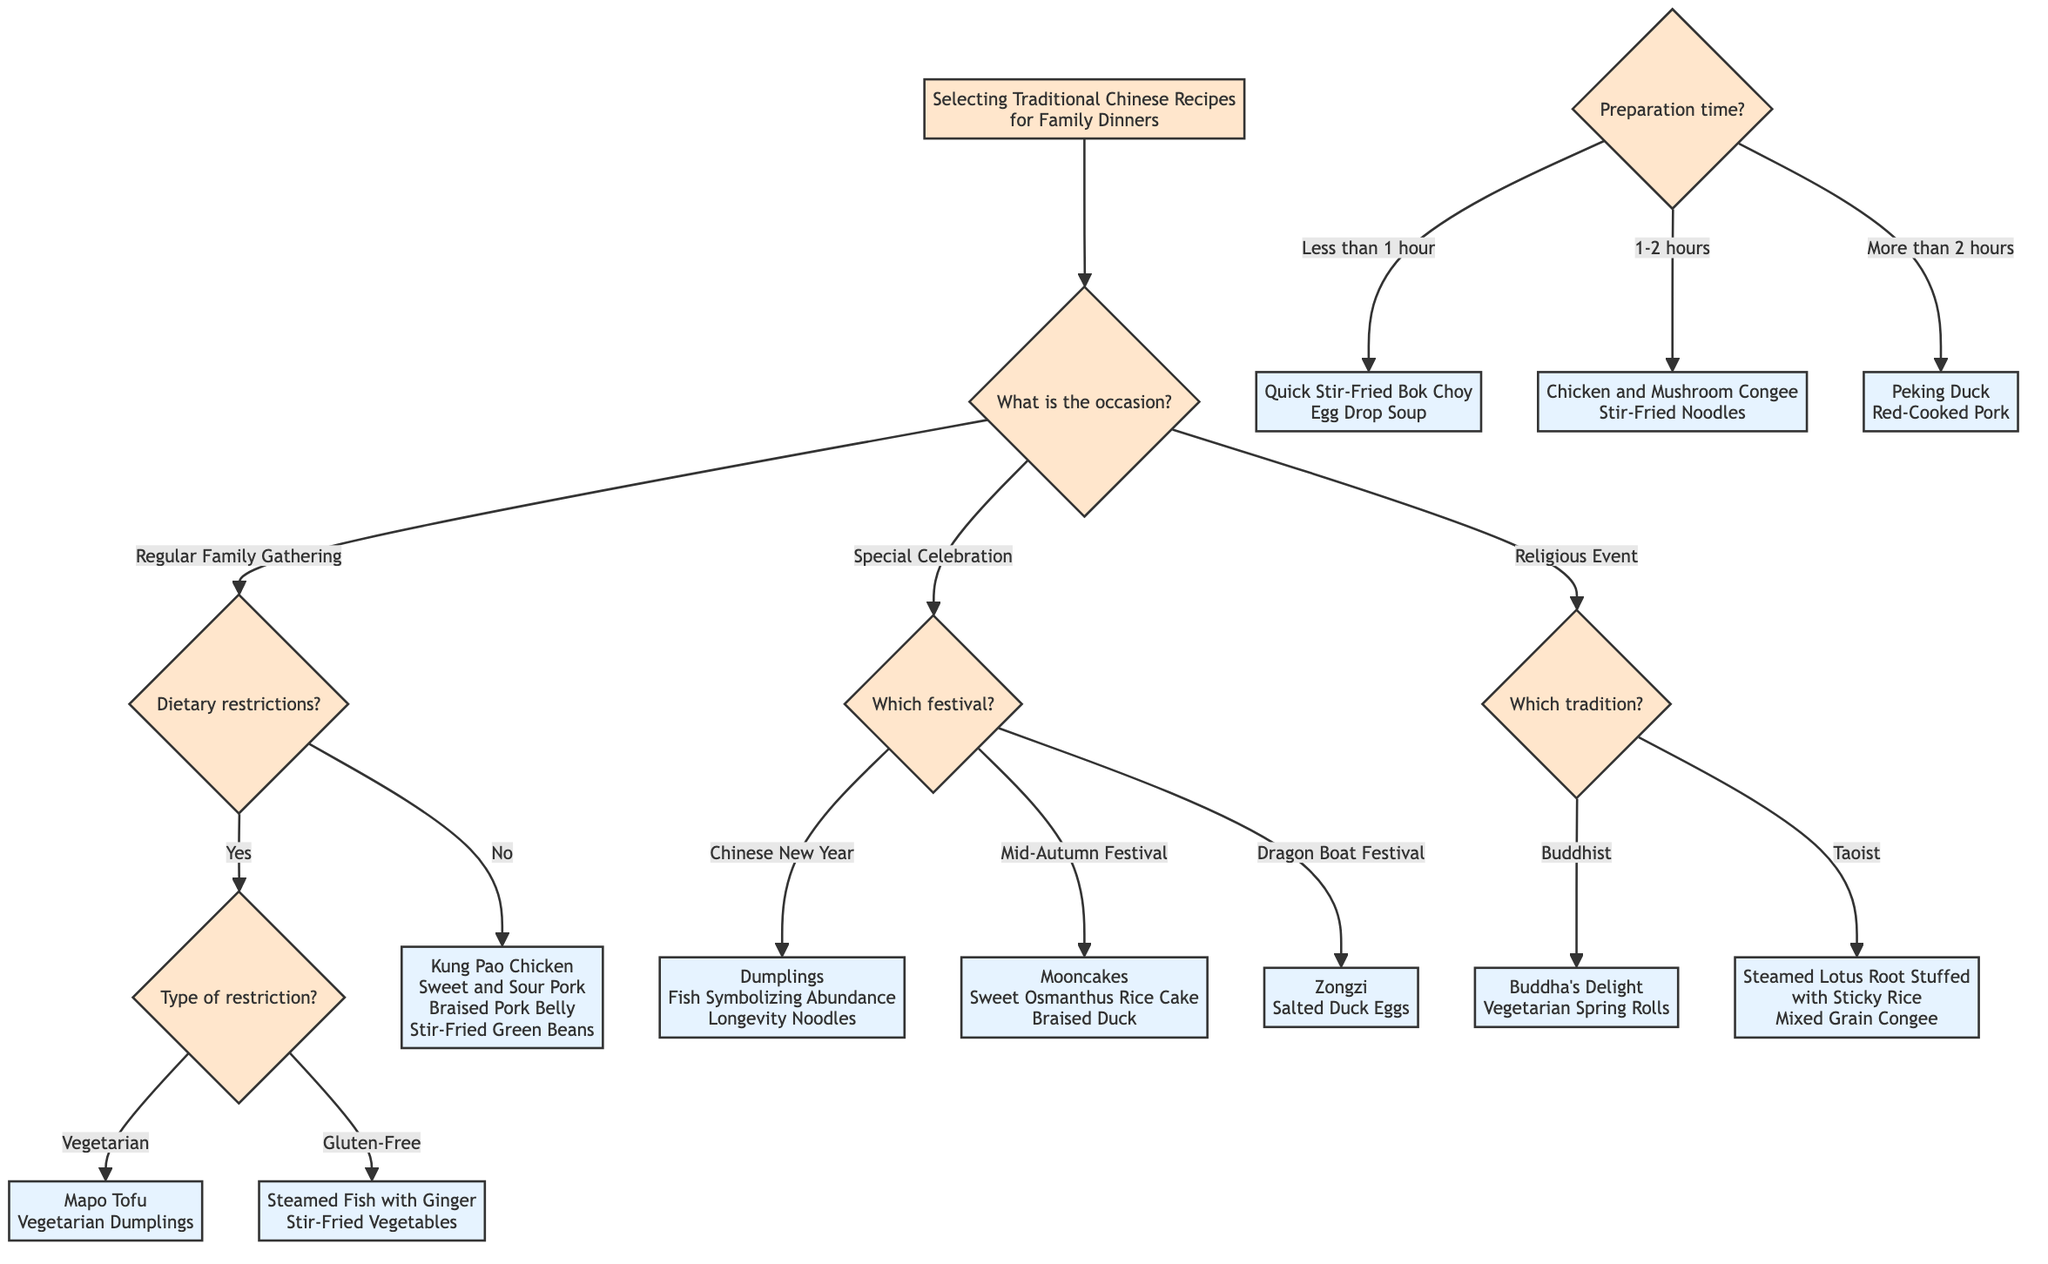What is the first question in the decision tree? The first question in the decision tree is located right below the starting node and it asks about the occasion for the meal. This is indicated by the connection from the starting node to the first decision node.
Answer: What is the occasion? How many options are there under "Special Celebration"? Under "Special Celebration," there are three options represented as branches leading to different festivals: Chinese New Year, Mid-Autumn Festival, and Dragon Boat Festival. Counting these options gives a total of three.
Answer: 3 What are two dishes under the "Religious Event" where Buddhist tradition is honored? Under the "Religious Event" node, if we take the branch for the Buddhist tradition, the two dishes listed are Buddha's Delight and Vegetarian Spring Rolls. These are directly represented in the diagram as the final answers to that branch.
Answer: Buddha's Delight, Vegetarian Spring Rolls If family members have dietary restrictions and it is vegetarian, what are the recommended recipes? When family members have dietary restrictions and the type specified is vegetarian, the decision tree indicates two recipes: Mapo Tofu and Vegetarian Dumplings. This follows the path from the dietary restrictions question to the vegetarian answer.
Answer: Mapo Tofu, Vegetarian Dumplings What is the dish recommended if there is no dietary restriction and the occasion is a Regular Family Gathering? If there is no dietary restriction for a Regular Family Gathering, the decision tree lists four dishes: Kung Pao Chicken, Sweet and Sour Pork, Braised Pork Belly, and Stir-Fried Green Beans. These are all options provided under that condition.
Answer: Kung Pao Chicken, Sweet and Sour Pork, Braised Pork Belly, Stir-Fried Green Beans What is the last option under the question of "Preparation time"? The decision tree lists three preparation time categories, with the last option being "More than 2 hours." This indicates the upper time limit for preparation, depicted as the final branch.
Answer: More than 2 hours What recipe would you choose for a Mid-Autumn Festival? For the Mid-Autumn Festival, the options in the decision tree are Mooncakes, Sweet Osmanthus Rice Cake, and Braised Duck. Selecting this festival leads to these specific dish recommendations.
Answer: Mooncakes, Sweet Osmanthus Rice Cake, Braised Duck What is the connection between "Regular Family Gathering" and "Religious Event"? The connection between "Regular Family Gathering" and "Religious Event" is structured as separate branches coming from the same initial node, indicating different paths to follow based on the occasion; they do not connect directly. Each represents a different decision to consider.
Answer: Separate branches 